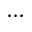<formula> <loc_0><loc_0><loc_500><loc_500>\cdots</formula> 